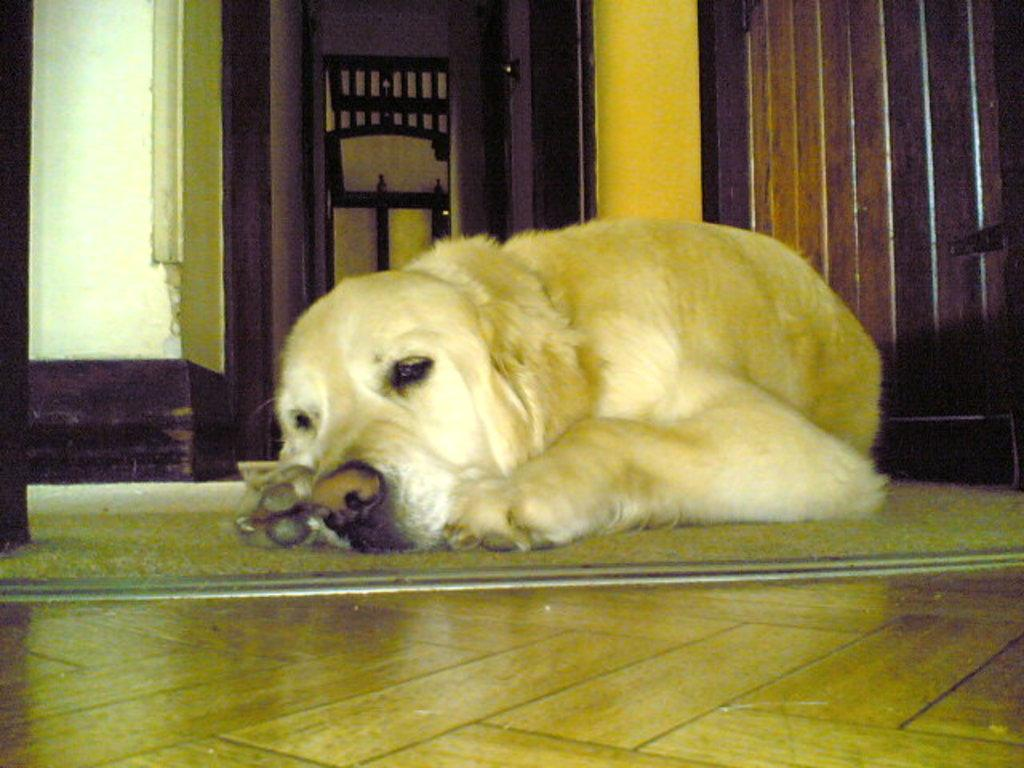What type of animal is present in the image? There is a dog in the image. What is the dog doing in the image? The dog is lying on the floor. What can be seen behind the dog? There is a wall behind the dog. Can you identify any architectural features in the image? Yes, there is a door in the image. How many apples are hanging from the wall in the image? There are no apples present in the image. What type of spiders can be seen crawling on the dog in the image? There are no spiders present in the image, and the dog is not interacting with any spiders. 